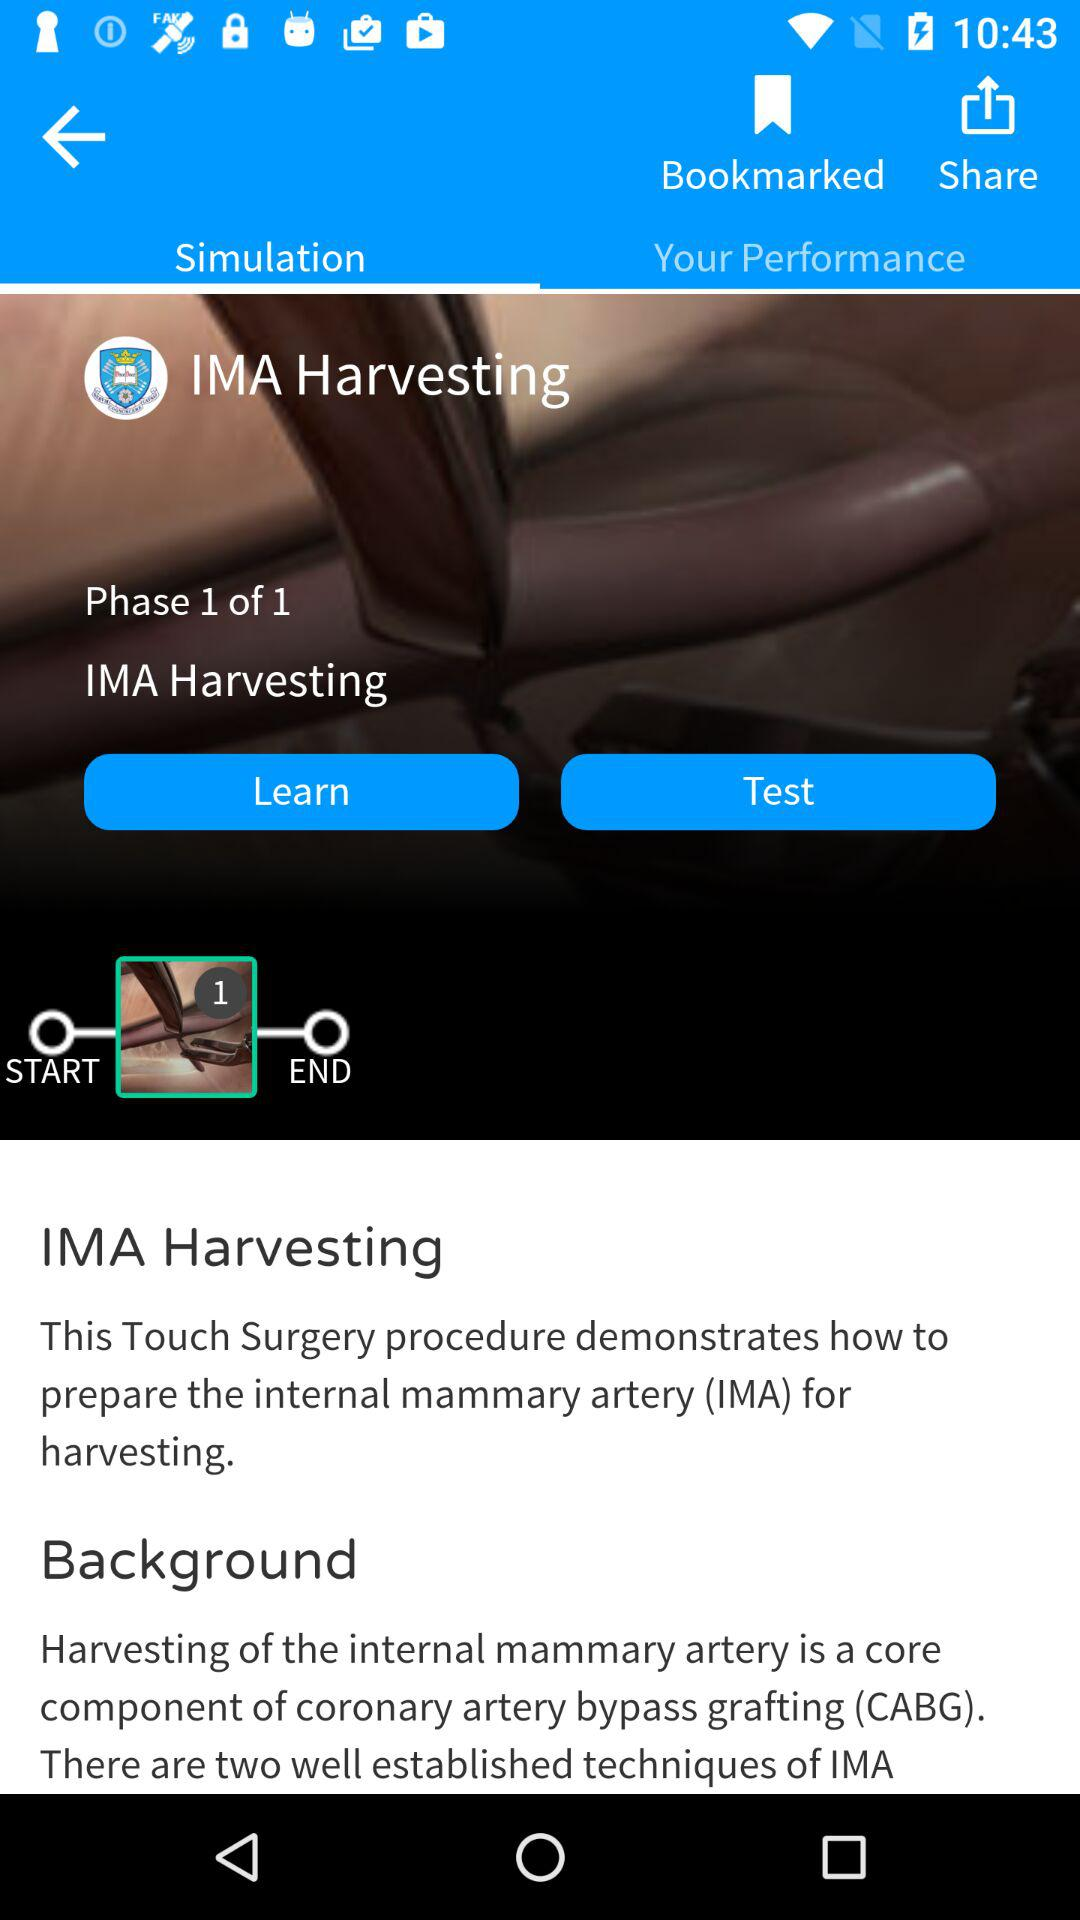How many phases are available for IMA Harvesting? There is 1 phase available for IMA Harvesting. 